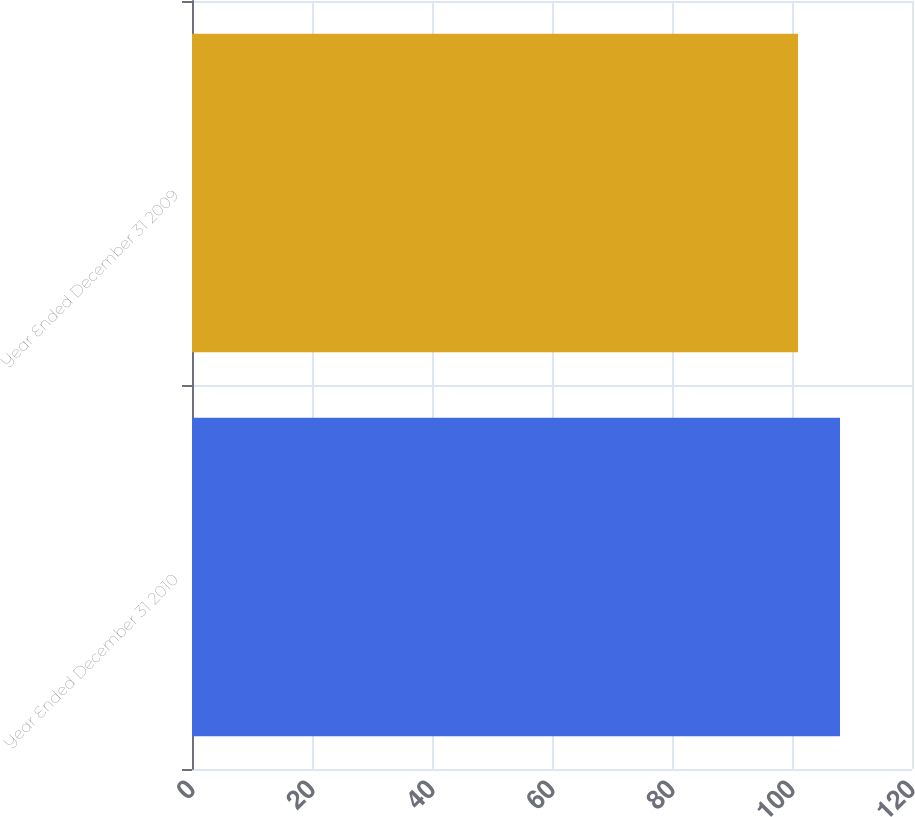Convert chart. <chart><loc_0><loc_0><loc_500><loc_500><bar_chart><fcel>Year Ended December 31 2010<fcel>Year Ended December 31 2009<nl><fcel>108<fcel>101<nl></chart> 